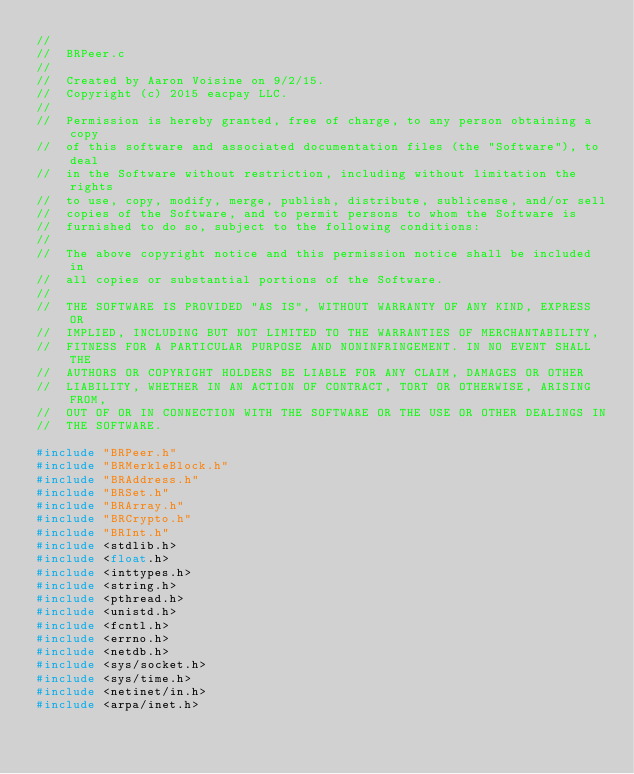<code> <loc_0><loc_0><loc_500><loc_500><_C_>//
//  BRPeer.c
//
//  Created by Aaron Voisine on 9/2/15.
//  Copyright (c) 2015 eacpay LLC.
//
//  Permission is hereby granted, free of charge, to any person obtaining a copy
//  of this software and associated documentation files (the "Software"), to deal
//  in the Software without restriction, including without limitation the rights
//  to use, copy, modify, merge, publish, distribute, sublicense, and/or sell
//  copies of the Software, and to permit persons to whom the Software is
//  furnished to do so, subject to the following conditions:
//
//  The above copyright notice and this permission notice shall be included in
//  all copies or substantial portions of the Software.
//
//  THE SOFTWARE IS PROVIDED "AS IS", WITHOUT WARRANTY OF ANY KIND, EXPRESS OR
//  IMPLIED, INCLUDING BUT NOT LIMITED TO THE WARRANTIES OF MERCHANTABILITY,
//  FITNESS FOR A PARTICULAR PURPOSE AND NONINFRINGEMENT. IN NO EVENT SHALL THE
//  AUTHORS OR COPYRIGHT HOLDERS BE LIABLE FOR ANY CLAIM, DAMAGES OR OTHER
//  LIABILITY, WHETHER IN AN ACTION OF CONTRACT, TORT OR OTHERWISE, ARISING FROM,
//  OUT OF OR IN CONNECTION WITH THE SOFTWARE OR THE USE OR OTHER DEALINGS IN
//  THE SOFTWARE.

#include "BRPeer.h"
#include "BRMerkleBlock.h"
#include "BRAddress.h"
#include "BRSet.h"
#include "BRArray.h"
#include "BRCrypto.h"
#include "BRInt.h"
#include <stdlib.h>
#include <float.h>
#include <inttypes.h>
#include <string.h>
#include <pthread.h>
#include <unistd.h>
#include <fcntl.h>
#include <errno.h>
#include <netdb.h>
#include <sys/socket.h>
#include <sys/time.h>
#include <netinet/in.h>	
#include <arpa/inet.h>
</code> 